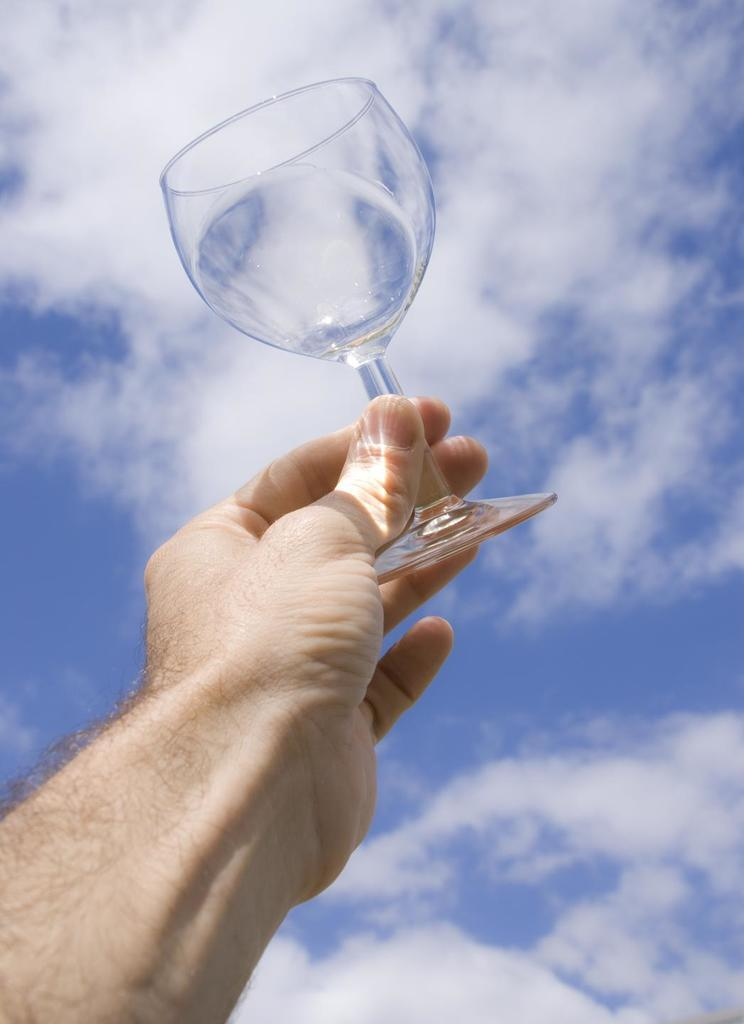What part of a person is visible in the image? There is a hand of a person in the image. What is the hand holding in the image? The hand is holding a glass. How is the glass positioned in relation to the sky? The glass is pointing towards the sky. What is the person talking about in the image? There is no indication in the image that the person is talking or expressing any desires or records. 